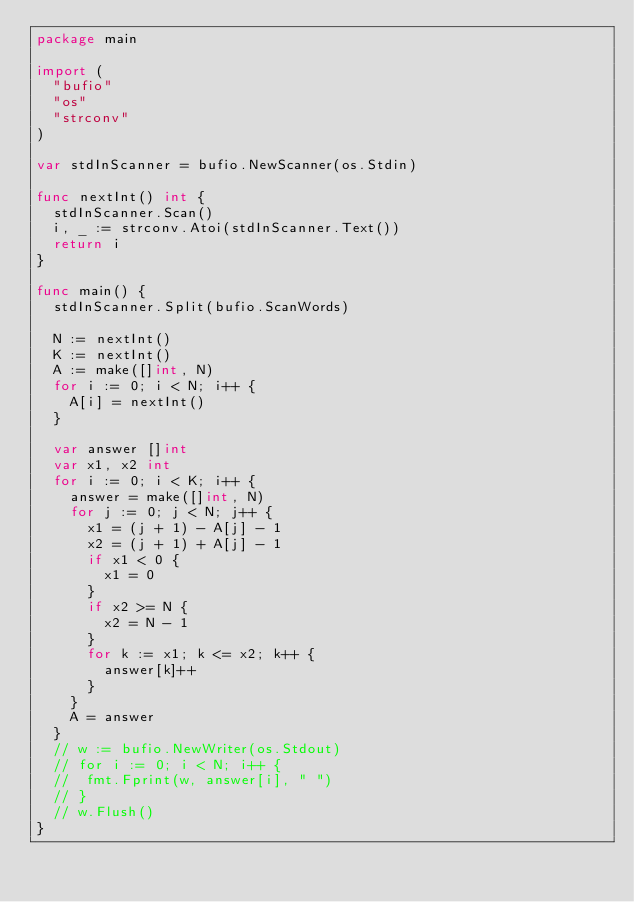<code> <loc_0><loc_0><loc_500><loc_500><_Go_>package main

import (
	"bufio"
	"os"
	"strconv"
)

var stdInScanner = bufio.NewScanner(os.Stdin)

func nextInt() int {
	stdInScanner.Scan()
	i, _ := strconv.Atoi(stdInScanner.Text())
	return i
}

func main() {
	stdInScanner.Split(bufio.ScanWords)

	N := nextInt()
	K := nextInt()
	A := make([]int, N)
	for i := 0; i < N; i++ {
		A[i] = nextInt()
	}

	var answer []int
	var x1, x2 int
	for i := 0; i < K; i++ {
		answer = make([]int, N)
		for j := 0; j < N; j++ {
			x1 = (j + 1) - A[j] - 1
			x2 = (j + 1) + A[j] - 1
			if x1 < 0 {
				x1 = 0
			}
			if x2 >= N {
				x2 = N - 1
			}
			for k := x1; k <= x2; k++ {
				answer[k]++
			}
		}
		A = answer
	}
	// w := bufio.NewWriter(os.Stdout)
	// for i := 0; i < N; i++ {
	// 	fmt.Fprint(w, answer[i], " ")
	// }
	// w.Flush()
}
</code> 